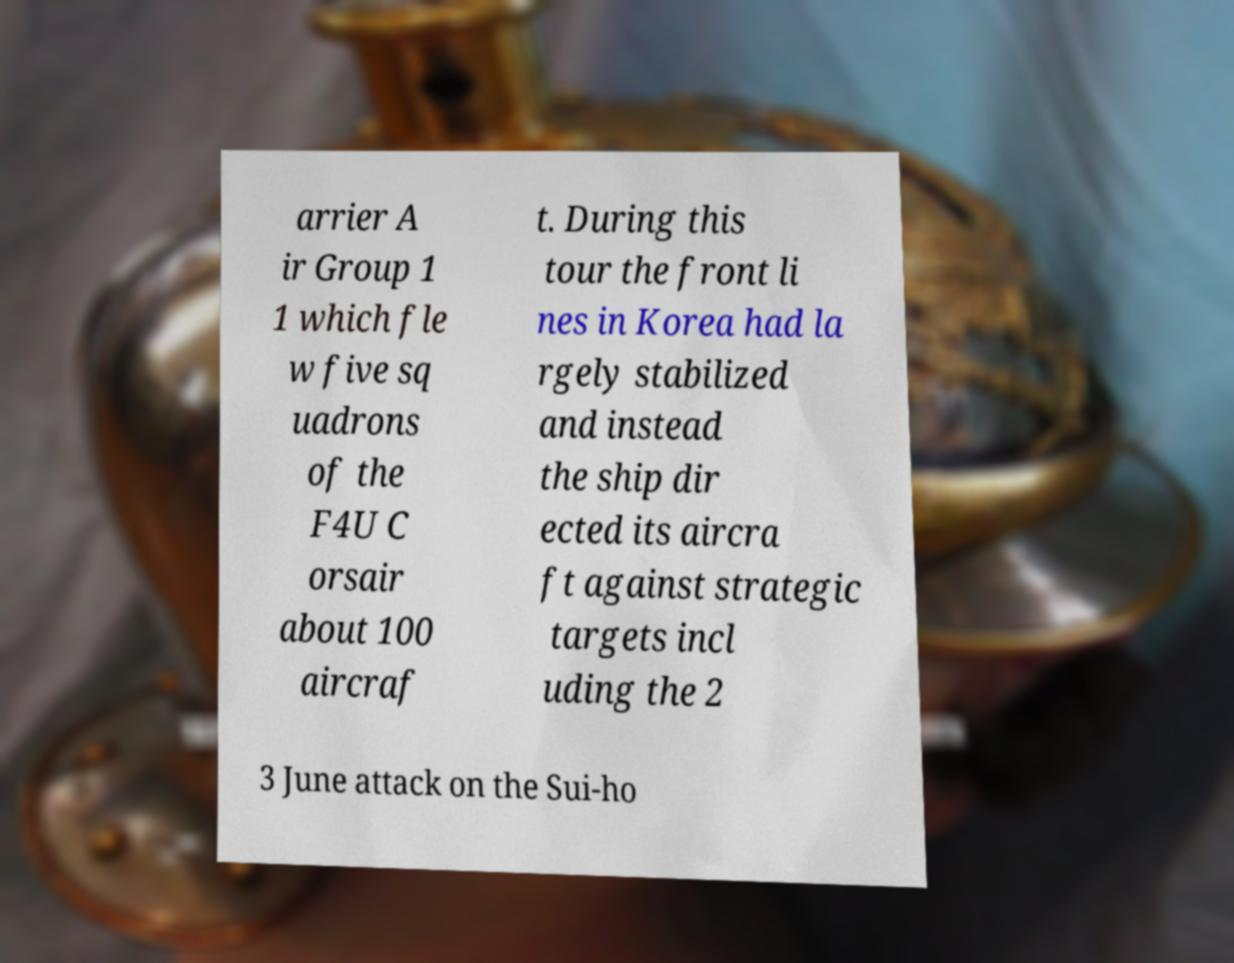Can you read and provide the text displayed in the image?This photo seems to have some interesting text. Can you extract and type it out for me? arrier A ir Group 1 1 which fle w five sq uadrons of the F4U C orsair about 100 aircraf t. During this tour the front li nes in Korea had la rgely stabilized and instead the ship dir ected its aircra ft against strategic targets incl uding the 2 3 June attack on the Sui-ho 